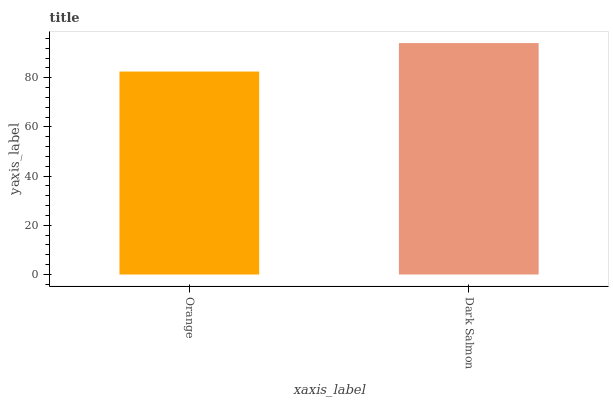Is Orange the minimum?
Answer yes or no. Yes. Is Dark Salmon the maximum?
Answer yes or no. Yes. Is Dark Salmon the minimum?
Answer yes or no. No. Is Dark Salmon greater than Orange?
Answer yes or no. Yes. Is Orange less than Dark Salmon?
Answer yes or no. Yes. Is Orange greater than Dark Salmon?
Answer yes or no. No. Is Dark Salmon less than Orange?
Answer yes or no. No. Is Dark Salmon the high median?
Answer yes or no. Yes. Is Orange the low median?
Answer yes or no. Yes. Is Orange the high median?
Answer yes or no. No. Is Dark Salmon the low median?
Answer yes or no. No. 